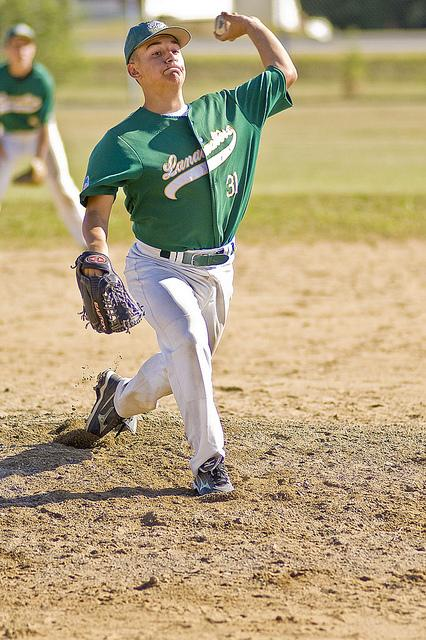Where does this man? Please explain your reasoning. pitchers mound. A man in a baseball uniform is stepping forward to throw the ball with purpose from an elevated mound of sand. pitchers throw from an elevated mound of sand in the center of baseball diamonds. 